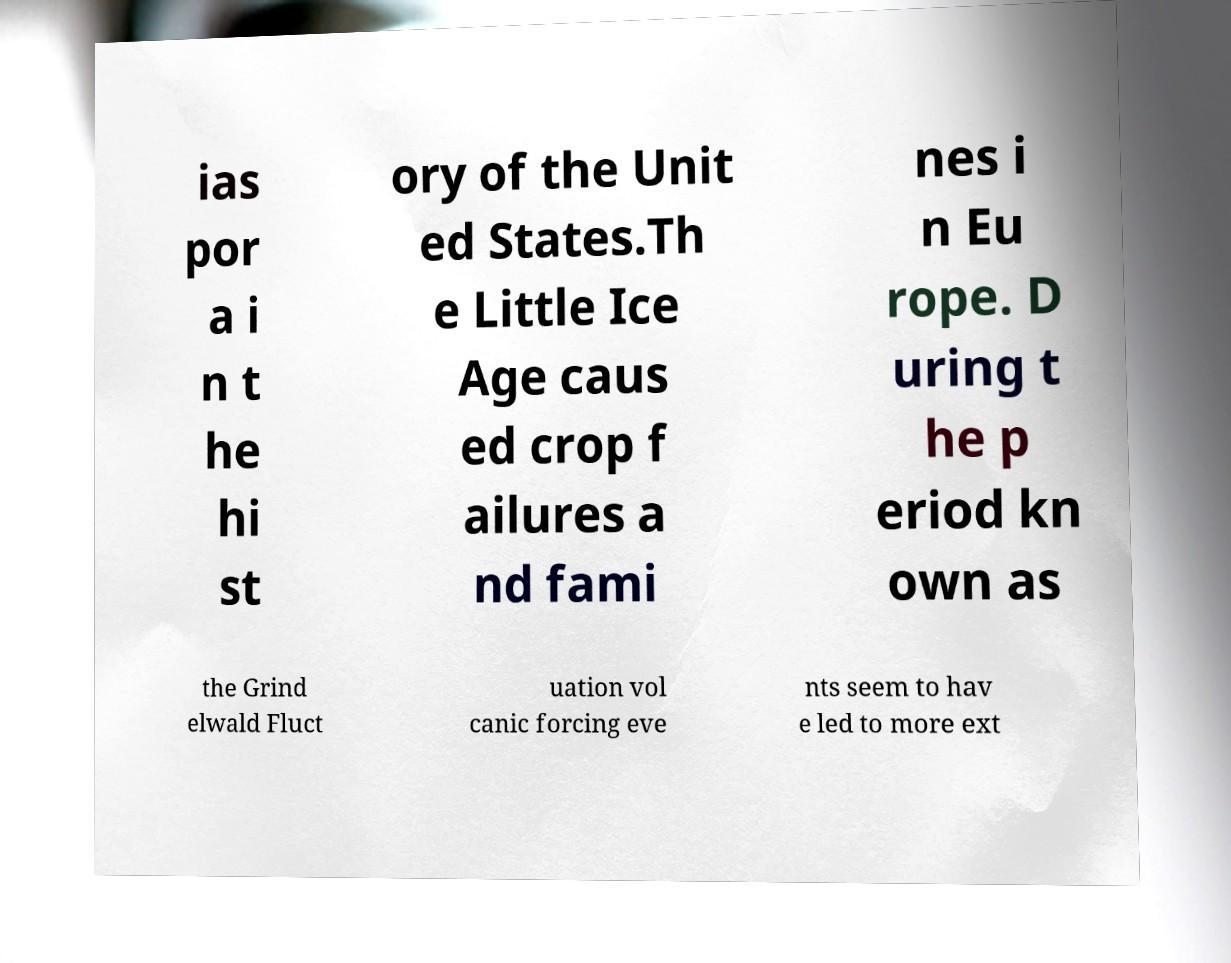Can you read and provide the text displayed in the image?This photo seems to have some interesting text. Can you extract and type it out for me? ias por a i n t he hi st ory of the Unit ed States.Th e Little Ice Age caus ed crop f ailures a nd fami nes i n Eu rope. D uring t he p eriod kn own as the Grind elwald Fluct uation vol canic forcing eve nts seem to hav e led to more ext 